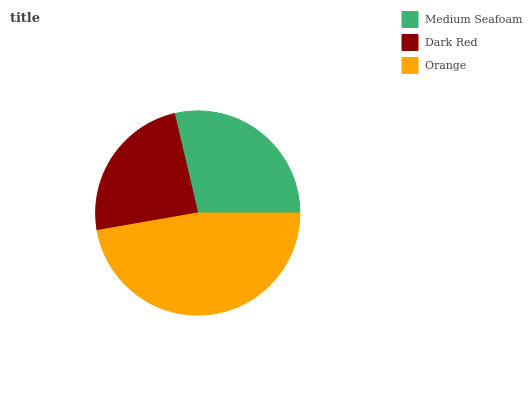Is Dark Red the minimum?
Answer yes or no. Yes. Is Orange the maximum?
Answer yes or no. Yes. Is Orange the minimum?
Answer yes or no. No. Is Dark Red the maximum?
Answer yes or no. No. Is Orange greater than Dark Red?
Answer yes or no. Yes. Is Dark Red less than Orange?
Answer yes or no. Yes. Is Dark Red greater than Orange?
Answer yes or no. No. Is Orange less than Dark Red?
Answer yes or no. No. Is Medium Seafoam the high median?
Answer yes or no. Yes. Is Medium Seafoam the low median?
Answer yes or no. Yes. Is Orange the high median?
Answer yes or no. No. Is Orange the low median?
Answer yes or no. No. 